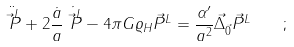Convert formula to latex. <formula><loc_0><loc_0><loc_500><loc_500>\ddot { \vec { P } ^ { L } } + 2 \frac { \dot { a } } { a } \dot { \vec { P } ^ { L } } - 4 \pi G \varrho _ { H } \vec { P } ^ { L } = \frac { \alpha ^ { \prime } } { a ^ { 2 } } \vec { \Delta } _ { \vec { 0 } } \vec { P } ^ { L } \quad ;</formula> 